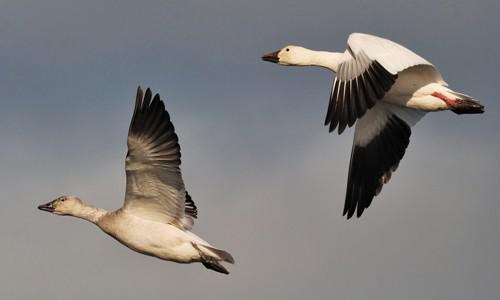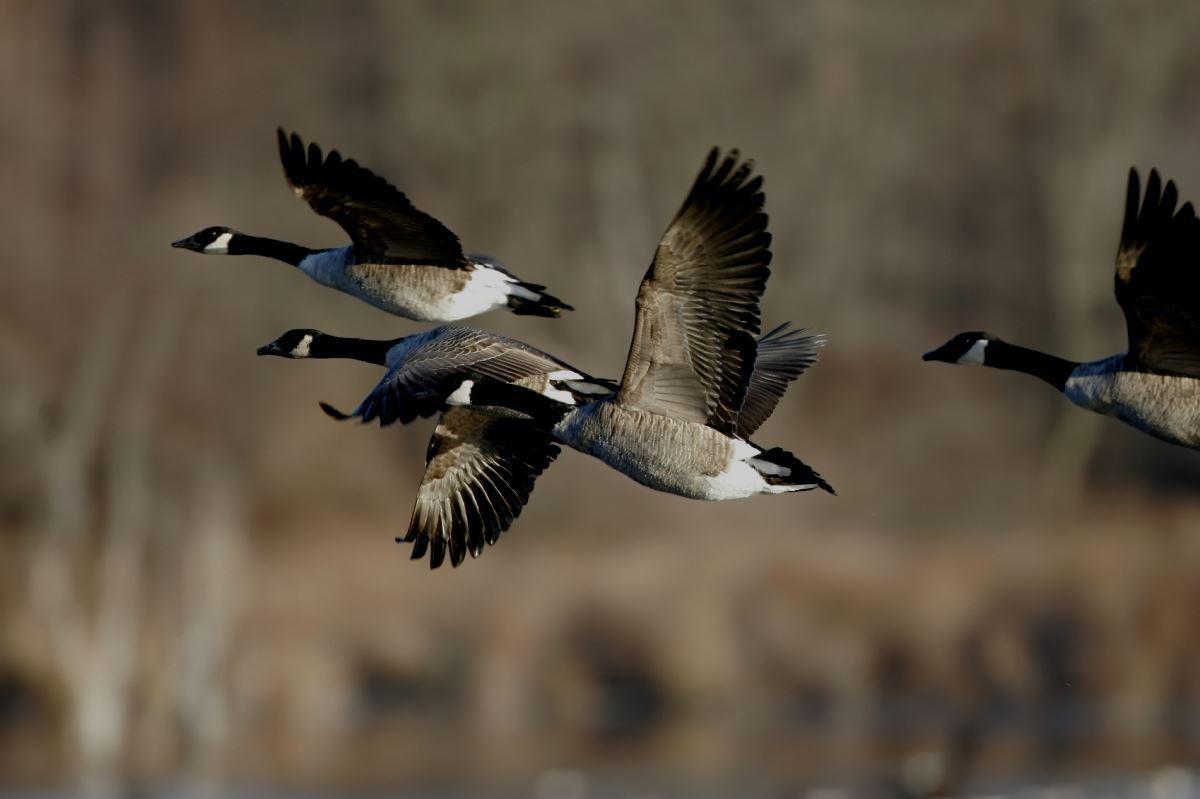The first image is the image on the left, the second image is the image on the right. For the images displayed, is the sentence "One image shows at least four black-necked geese flying leftward, and the other image shows no more than two geese flying and they do not have black necks." factually correct? Answer yes or no. Yes. The first image is the image on the left, the second image is the image on the right. Examine the images to the left and right. Is the description "There is no more than two ducks in the left image." accurate? Answer yes or no. Yes. 